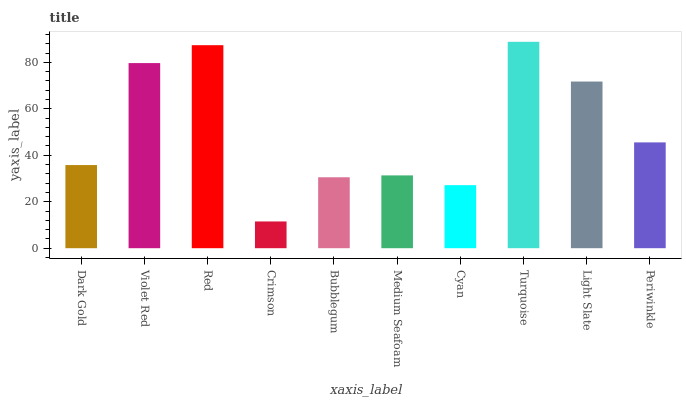Is Crimson the minimum?
Answer yes or no. Yes. Is Turquoise the maximum?
Answer yes or no. Yes. Is Violet Red the minimum?
Answer yes or no. No. Is Violet Red the maximum?
Answer yes or no. No. Is Violet Red greater than Dark Gold?
Answer yes or no. Yes. Is Dark Gold less than Violet Red?
Answer yes or no. Yes. Is Dark Gold greater than Violet Red?
Answer yes or no. No. Is Violet Red less than Dark Gold?
Answer yes or no. No. Is Periwinkle the high median?
Answer yes or no. Yes. Is Dark Gold the low median?
Answer yes or no. Yes. Is Turquoise the high median?
Answer yes or no. No. Is Medium Seafoam the low median?
Answer yes or no. No. 